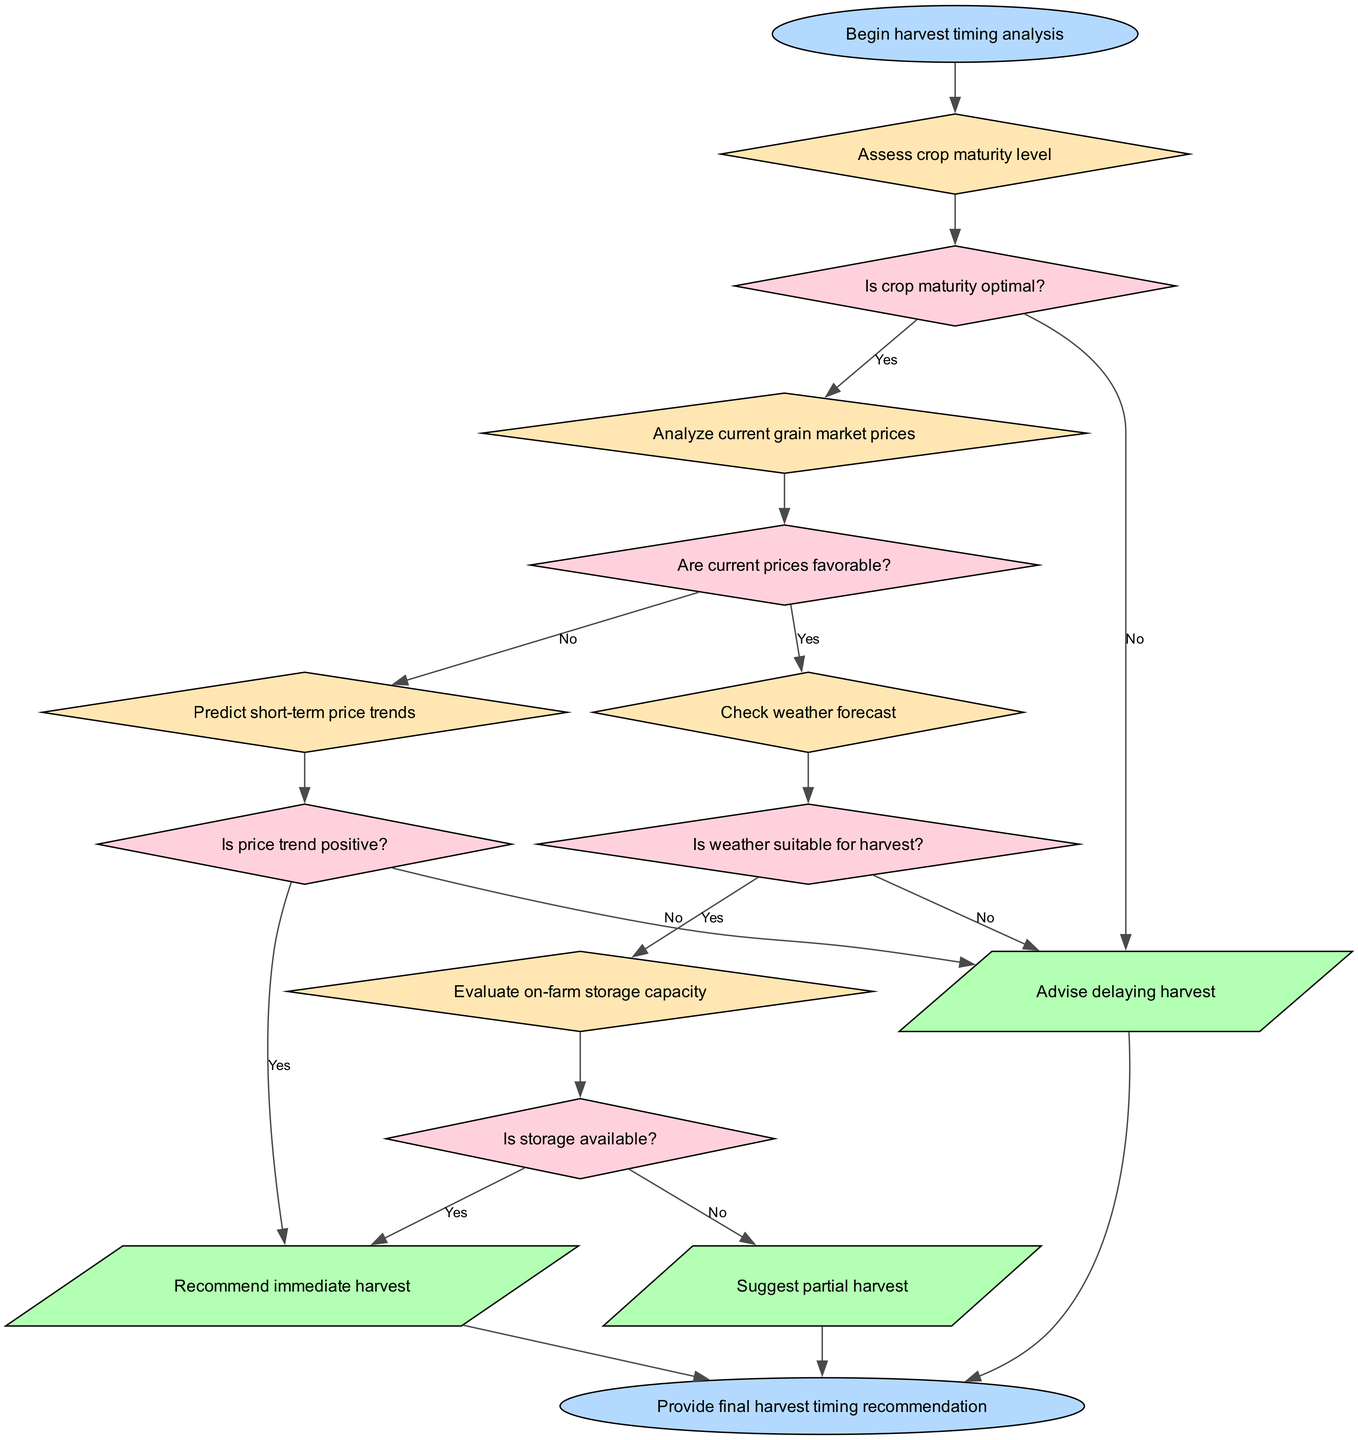What is the starting point of the decision-making process? The starting point of the decision-making process is labeled as "Begin harvest timing analysis" in the diagram. The diagram clearly denotes this as the initial node.
Answer: Begin harvest timing analysis How many decisions are there in the flowchart? The flowchart contains five decision nodes, each representing a step in assessing the harvest timing process. I counted the decision nodes as listed in the data.
Answer: Five What happens if the crop maturity is not optimal? If the crop maturity is not optimal, the flowchart leads to the action node advising to "delay harvest." This is clear from the connection from the maturity assessment decision to this outcome.
Answer: Advise delaying harvest What is checked after assessing crop maturity? After assessing crop maturity, the next step in the flowchart is to "analyze current grain market prices." The flowchart follows the logical sequence from one decision to the next.
Answer: Analyze current grain market prices If the current prices are not favorable, what is the next step? If the current prices are not favorable, the flowchart indicates moving to "predict short-term price trends." This decision follows the unfavorable price assessment as the subsequent step.
Answer: Predict short-term price trends What condition is checked after determining the suitability of the weather? After determining whether the weather is suitable, the next condition checked is "Evaluate on-farm storage capacity." This flow follows the inquiry about the weather, establishing continuity in the decision process.
Answer: Evaluate on-farm storage capacity How does the process end if a partial harvest is suggested? If a partial harvest is suggested, the flowchart leads to the end node, indicating that the final harvest timing recommendation is provided. This outlines how the process concludes based on prior conditions.
Answer: Provide final harvest timing recommendation What is the outcome if all conditions for storage availability are met? If all conditions for storage availability are met, the outcome is to "recommend immediate harvest," shown as the result of successful evaluation through the storage decision path.
Answer: Recommend immediate harvest 